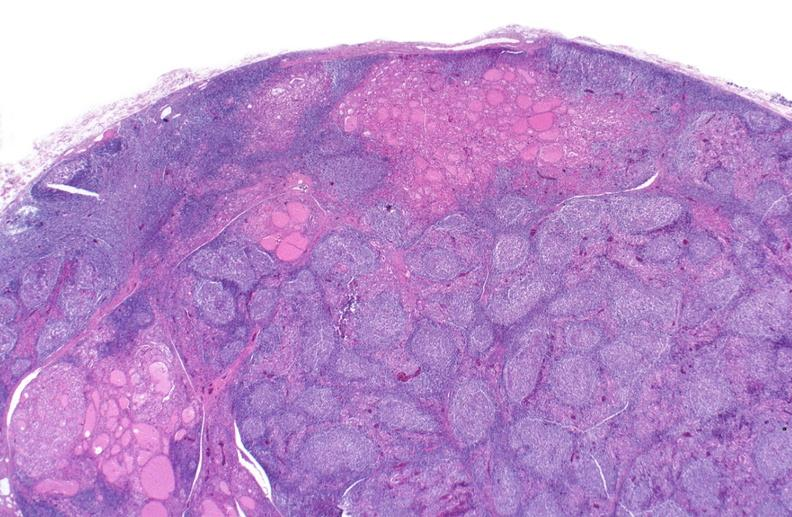what does this image show?
Answer the question using a single word or phrase. Hashimoto 's thyroiditis 